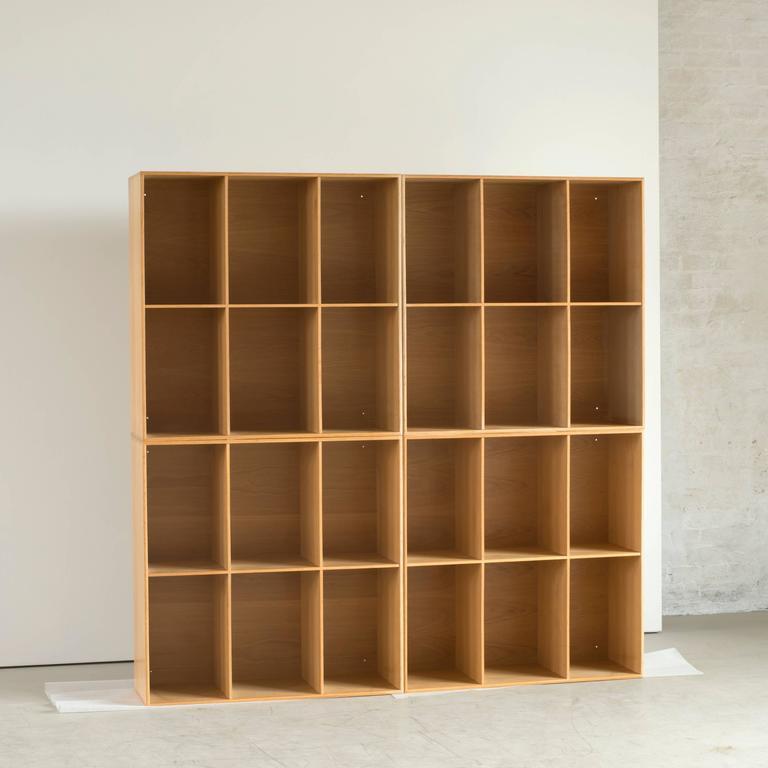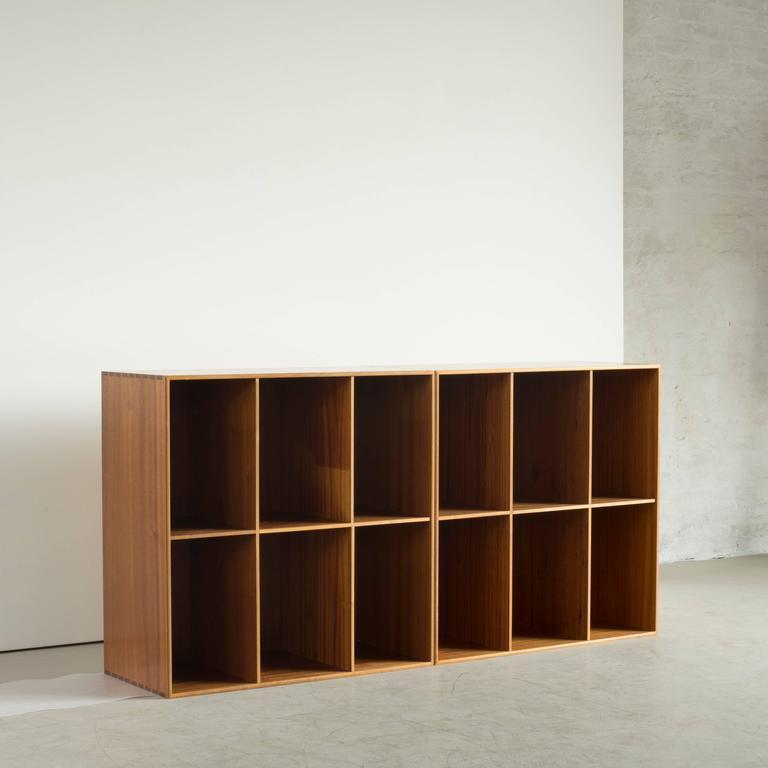The first image is the image on the left, the second image is the image on the right. For the images shown, is this caption "One piece of furniture has exactly five shelves." true? Answer yes or no. No. 